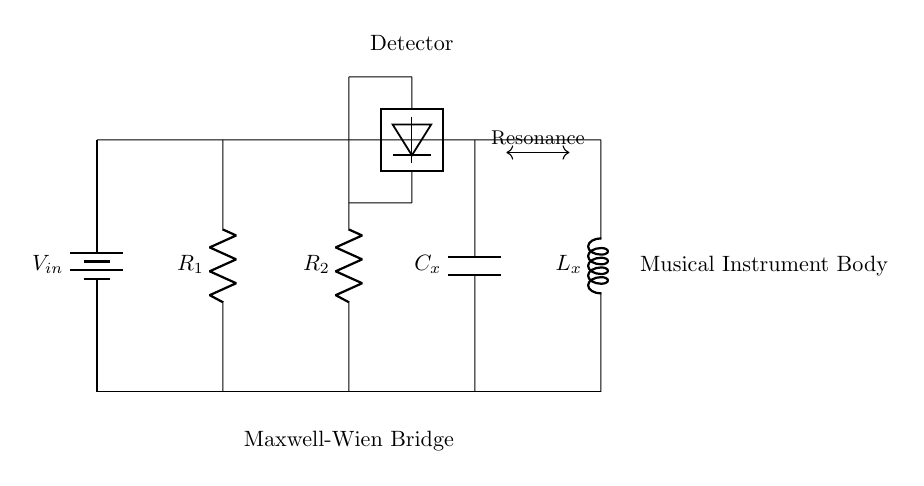What is the input component of the circuit? The input component is the battery, which provides the voltage to the circuit.
Answer: battery What type of circuit is depicted? This circuit is a Maxwell-Wien Bridge, which is specifically used for measuring unknown components.
Answer: Maxwell-Wien Bridge Which components are used to detect resonance? The detector is the component used to identify resonance within the circuit.
Answer: detector How many resistors are in the circuit? There are two resistors present in the circuit, denoted as R1 and R2.
Answer: 2 What is the role of the capacitor in this circuit? The capacitor, labeled Cx, is part of the bridge configuration, contributing to the overall impedance and resonance characteristics of the circuit.
Answer: Cx What is the significance of the musical instrument body in this circuit? The musical instrument body represents the load that interacts with the circuit components to produce the desired resonance.
Answer: Musical Instrument Body What does the arrow indicate between Cx and Lx? The arrow signifies the relationship indicating resonance between the capacitor and inductor, showing their interaction in the circuit.
Answer: Resonance 